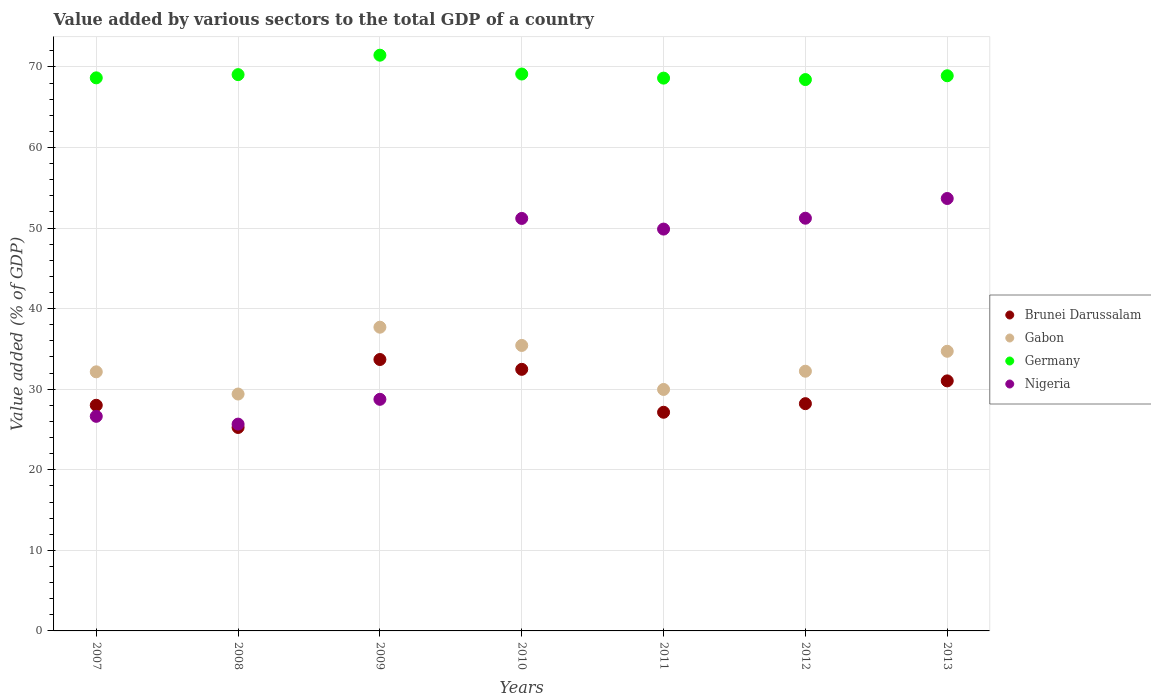Is the number of dotlines equal to the number of legend labels?
Your response must be concise. Yes. What is the value added by various sectors to the total GDP in Gabon in 2007?
Offer a terse response. 32.16. Across all years, what is the maximum value added by various sectors to the total GDP in Germany?
Keep it short and to the point. 71.46. Across all years, what is the minimum value added by various sectors to the total GDP in Germany?
Your response must be concise. 68.43. What is the total value added by various sectors to the total GDP in Germany in the graph?
Your answer should be compact. 484.2. What is the difference between the value added by various sectors to the total GDP in Germany in 2007 and that in 2012?
Provide a succinct answer. 0.21. What is the difference between the value added by various sectors to the total GDP in Gabon in 2011 and the value added by various sectors to the total GDP in Brunei Darussalam in 2012?
Provide a short and direct response. 1.76. What is the average value added by various sectors to the total GDP in Gabon per year?
Ensure brevity in your answer.  33.09. In the year 2007, what is the difference between the value added by various sectors to the total GDP in Gabon and value added by various sectors to the total GDP in Brunei Darussalam?
Your answer should be very brief. 4.15. What is the ratio of the value added by various sectors to the total GDP in Nigeria in 2007 to that in 2009?
Your response must be concise. 0.93. Is the value added by various sectors to the total GDP in Germany in 2010 less than that in 2012?
Provide a short and direct response. No. Is the difference between the value added by various sectors to the total GDP in Gabon in 2012 and 2013 greater than the difference between the value added by various sectors to the total GDP in Brunei Darussalam in 2012 and 2013?
Offer a very short reply. Yes. What is the difference between the highest and the second highest value added by various sectors to the total GDP in Germany?
Provide a succinct answer. 2.34. What is the difference between the highest and the lowest value added by various sectors to the total GDP in Nigeria?
Your answer should be compact. 28. In how many years, is the value added by various sectors to the total GDP in Gabon greater than the average value added by various sectors to the total GDP in Gabon taken over all years?
Your answer should be compact. 3. What is the difference between two consecutive major ticks on the Y-axis?
Your answer should be compact. 10. Where does the legend appear in the graph?
Give a very brief answer. Center right. How many legend labels are there?
Your response must be concise. 4. How are the legend labels stacked?
Offer a terse response. Vertical. What is the title of the graph?
Give a very brief answer. Value added by various sectors to the total GDP of a country. Does "Libya" appear as one of the legend labels in the graph?
Provide a short and direct response. No. What is the label or title of the X-axis?
Your response must be concise. Years. What is the label or title of the Y-axis?
Your response must be concise. Value added (% of GDP). What is the Value added (% of GDP) of Brunei Darussalam in 2007?
Give a very brief answer. 28.01. What is the Value added (% of GDP) in Gabon in 2007?
Give a very brief answer. 32.16. What is the Value added (% of GDP) in Germany in 2007?
Provide a succinct answer. 68.64. What is the Value added (% of GDP) in Nigeria in 2007?
Offer a very short reply. 26.63. What is the Value added (% of GDP) of Brunei Darussalam in 2008?
Ensure brevity in your answer.  25.25. What is the Value added (% of GDP) of Gabon in 2008?
Keep it short and to the point. 29.4. What is the Value added (% of GDP) of Germany in 2008?
Your answer should be very brief. 69.04. What is the Value added (% of GDP) in Nigeria in 2008?
Give a very brief answer. 25.67. What is the Value added (% of GDP) in Brunei Darussalam in 2009?
Keep it short and to the point. 33.69. What is the Value added (% of GDP) in Gabon in 2009?
Your response must be concise. 37.7. What is the Value added (% of GDP) in Germany in 2009?
Your response must be concise. 71.46. What is the Value added (% of GDP) of Nigeria in 2009?
Your answer should be compact. 28.74. What is the Value added (% of GDP) of Brunei Darussalam in 2010?
Provide a short and direct response. 32.47. What is the Value added (% of GDP) in Gabon in 2010?
Make the answer very short. 35.43. What is the Value added (% of GDP) in Germany in 2010?
Offer a very short reply. 69.12. What is the Value added (% of GDP) in Nigeria in 2010?
Make the answer very short. 51.2. What is the Value added (% of GDP) of Brunei Darussalam in 2011?
Give a very brief answer. 27.14. What is the Value added (% of GDP) of Gabon in 2011?
Offer a very short reply. 29.97. What is the Value added (% of GDP) in Germany in 2011?
Ensure brevity in your answer.  68.61. What is the Value added (% of GDP) of Nigeria in 2011?
Give a very brief answer. 49.87. What is the Value added (% of GDP) of Brunei Darussalam in 2012?
Offer a terse response. 28.21. What is the Value added (% of GDP) of Gabon in 2012?
Your response must be concise. 32.23. What is the Value added (% of GDP) of Germany in 2012?
Offer a very short reply. 68.43. What is the Value added (% of GDP) in Nigeria in 2012?
Ensure brevity in your answer.  51.22. What is the Value added (% of GDP) of Brunei Darussalam in 2013?
Your answer should be compact. 31.03. What is the Value added (% of GDP) in Gabon in 2013?
Ensure brevity in your answer.  34.71. What is the Value added (% of GDP) in Germany in 2013?
Keep it short and to the point. 68.9. What is the Value added (% of GDP) in Nigeria in 2013?
Make the answer very short. 53.67. Across all years, what is the maximum Value added (% of GDP) of Brunei Darussalam?
Your answer should be very brief. 33.69. Across all years, what is the maximum Value added (% of GDP) in Gabon?
Your answer should be compact. 37.7. Across all years, what is the maximum Value added (% of GDP) in Germany?
Provide a succinct answer. 71.46. Across all years, what is the maximum Value added (% of GDP) of Nigeria?
Your response must be concise. 53.67. Across all years, what is the minimum Value added (% of GDP) in Brunei Darussalam?
Provide a succinct answer. 25.25. Across all years, what is the minimum Value added (% of GDP) of Gabon?
Ensure brevity in your answer.  29.4. Across all years, what is the minimum Value added (% of GDP) in Germany?
Offer a very short reply. 68.43. Across all years, what is the minimum Value added (% of GDP) in Nigeria?
Ensure brevity in your answer.  25.67. What is the total Value added (% of GDP) in Brunei Darussalam in the graph?
Ensure brevity in your answer.  205.79. What is the total Value added (% of GDP) of Gabon in the graph?
Make the answer very short. 231.6. What is the total Value added (% of GDP) in Germany in the graph?
Your answer should be very brief. 484.2. What is the total Value added (% of GDP) of Nigeria in the graph?
Your response must be concise. 287.01. What is the difference between the Value added (% of GDP) of Brunei Darussalam in 2007 and that in 2008?
Give a very brief answer. 2.75. What is the difference between the Value added (% of GDP) in Gabon in 2007 and that in 2008?
Offer a terse response. 2.76. What is the difference between the Value added (% of GDP) in Germany in 2007 and that in 2008?
Give a very brief answer. -0.4. What is the difference between the Value added (% of GDP) of Nigeria in 2007 and that in 2008?
Offer a very short reply. 0.97. What is the difference between the Value added (% of GDP) of Brunei Darussalam in 2007 and that in 2009?
Offer a terse response. -5.68. What is the difference between the Value added (% of GDP) in Gabon in 2007 and that in 2009?
Your response must be concise. -5.54. What is the difference between the Value added (% of GDP) of Germany in 2007 and that in 2009?
Give a very brief answer. -2.81. What is the difference between the Value added (% of GDP) in Nigeria in 2007 and that in 2009?
Provide a succinct answer. -2.11. What is the difference between the Value added (% of GDP) of Brunei Darussalam in 2007 and that in 2010?
Offer a terse response. -4.46. What is the difference between the Value added (% of GDP) of Gabon in 2007 and that in 2010?
Offer a very short reply. -3.27. What is the difference between the Value added (% of GDP) in Germany in 2007 and that in 2010?
Keep it short and to the point. -0.48. What is the difference between the Value added (% of GDP) of Nigeria in 2007 and that in 2010?
Your answer should be compact. -24.56. What is the difference between the Value added (% of GDP) of Brunei Darussalam in 2007 and that in 2011?
Offer a very short reply. 0.87. What is the difference between the Value added (% of GDP) in Gabon in 2007 and that in 2011?
Your response must be concise. 2.19. What is the difference between the Value added (% of GDP) in Germany in 2007 and that in 2011?
Offer a terse response. 0.03. What is the difference between the Value added (% of GDP) of Nigeria in 2007 and that in 2011?
Give a very brief answer. -23.24. What is the difference between the Value added (% of GDP) in Brunei Darussalam in 2007 and that in 2012?
Ensure brevity in your answer.  -0.2. What is the difference between the Value added (% of GDP) in Gabon in 2007 and that in 2012?
Make the answer very short. -0.08. What is the difference between the Value added (% of GDP) of Germany in 2007 and that in 2012?
Ensure brevity in your answer.  0.21. What is the difference between the Value added (% of GDP) of Nigeria in 2007 and that in 2012?
Your response must be concise. -24.59. What is the difference between the Value added (% of GDP) in Brunei Darussalam in 2007 and that in 2013?
Offer a very short reply. -3.03. What is the difference between the Value added (% of GDP) in Gabon in 2007 and that in 2013?
Make the answer very short. -2.55. What is the difference between the Value added (% of GDP) in Germany in 2007 and that in 2013?
Your response must be concise. -0.26. What is the difference between the Value added (% of GDP) in Nigeria in 2007 and that in 2013?
Offer a terse response. -27.04. What is the difference between the Value added (% of GDP) of Brunei Darussalam in 2008 and that in 2009?
Give a very brief answer. -8.43. What is the difference between the Value added (% of GDP) in Gabon in 2008 and that in 2009?
Offer a very short reply. -8.29. What is the difference between the Value added (% of GDP) of Germany in 2008 and that in 2009?
Give a very brief answer. -2.41. What is the difference between the Value added (% of GDP) of Nigeria in 2008 and that in 2009?
Offer a terse response. -3.08. What is the difference between the Value added (% of GDP) in Brunei Darussalam in 2008 and that in 2010?
Give a very brief answer. -7.22. What is the difference between the Value added (% of GDP) in Gabon in 2008 and that in 2010?
Keep it short and to the point. -6.03. What is the difference between the Value added (% of GDP) in Germany in 2008 and that in 2010?
Offer a terse response. -0.08. What is the difference between the Value added (% of GDP) in Nigeria in 2008 and that in 2010?
Provide a short and direct response. -25.53. What is the difference between the Value added (% of GDP) of Brunei Darussalam in 2008 and that in 2011?
Offer a very short reply. -1.89. What is the difference between the Value added (% of GDP) in Gabon in 2008 and that in 2011?
Provide a short and direct response. -0.57. What is the difference between the Value added (% of GDP) in Germany in 2008 and that in 2011?
Your response must be concise. 0.43. What is the difference between the Value added (% of GDP) in Nigeria in 2008 and that in 2011?
Your answer should be very brief. -24.21. What is the difference between the Value added (% of GDP) of Brunei Darussalam in 2008 and that in 2012?
Offer a very short reply. -2.95. What is the difference between the Value added (% of GDP) in Gabon in 2008 and that in 2012?
Offer a very short reply. -2.83. What is the difference between the Value added (% of GDP) of Germany in 2008 and that in 2012?
Make the answer very short. 0.61. What is the difference between the Value added (% of GDP) of Nigeria in 2008 and that in 2012?
Your answer should be very brief. -25.56. What is the difference between the Value added (% of GDP) of Brunei Darussalam in 2008 and that in 2013?
Your response must be concise. -5.78. What is the difference between the Value added (% of GDP) of Gabon in 2008 and that in 2013?
Offer a terse response. -5.31. What is the difference between the Value added (% of GDP) of Germany in 2008 and that in 2013?
Offer a very short reply. 0.14. What is the difference between the Value added (% of GDP) in Nigeria in 2008 and that in 2013?
Offer a terse response. -28. What is the difference between the Value added (% of GDP) in Brunei Darussalam in 2009 and that in 2010?
Your answer should be compact. 1.22. What is the difference between the Value added (% of GDP) in Gabon in 2009 and that in 2010?
Ensure brevity in your answer.  2.27. What is the difference between the Value added (% of GDP) in Germany in 2009 and that in 2010?
Provide a short and direct response. 2.34. What is the difference between the Value added (% of GDP) in Nigeria in 2009 and that in 2010?
Give a very brief answer. -22.45. What is the difference between the Value added (% of GDP) of Brunei Darussalam in 2009 and that in 2011?
Make the answer very short. 6.55. What is the difference between the Value added (% of GDP) in Gabon in 2009 and that in 2011?
Provide a short and direct response. 7.73. What is the difference between the Value added (% of GDP) in Germany in 2009 and that in 2011?
Your answer should be very brief. 2.85. What is the difference between the Value added (% of GDP) in Nigeria in 2009 and that in 2011?
Offer a terse response. -21.13. What is the difference between the Value added (% of GDP) in Brunei Darussalam in 2009 and that in 2012?
Your answer should be very brief. 5.48. What is the difference between the Value added (% of GDP) in Gabon in 2009 and that in 2012?
Keep it short and to the point. 5.46. What is the difference between the Value added (% of GDP) in Germany in 2009 and that in 2012?
Provide a short and direct response. 3.03. What is the difference between the Value added (% of GDP) in Nigeria in 2009 and that in 2012?
Offer a very short reply. -22.48. What is the difference between the Value added (% of GDP) of Brunei Darussalam in 2009 and that in 2013?
Ensure brevity in your answer.  2.65. What is the difference between the Value added (% of GDP) in Gabon in 2009 and that in 2013?
Your answer should be compact. 2.99. What is the difference between the Value added (% of GDP) of Germany in 2009 and that in 2013?
Your answer should be very brief. 2.55. What is the difference between the Value added (% of GDP) of Nigeria in 2009 and that in 2013?
Give a very brief answer. -24.93. What is the difference between the Value added (% of GDP) in Brunei Darussalam in 2010 and that in 2011?
Ensure brevity in your answer.  5.33. What is the difference between the Value added (% of GDP) of Gabon in 2010 and that in 2011?
Offer a terse response. 5.46. What is the difference between the Value added (% of GDP) of Germany in 2010 and that in 2011?
Offer a very short reply. 0.51. What is the difference between the Value added (% of GDP) of Nigeria in 2010 and that in 2011?
Give a very brief answer. 1.32. What is the difference between the Value added (% of GDP) in Brunei Darussalam in 2010 and that in 2012?
Provide a succinct answer. 4.26. What is the difference between the Value added (% of GDP) of Gabon in 2010 and that in 2012?
Provide a succinct answer. 3.2. What is the difference between the Value added (% of GDP) of Germany in 2010 and that in 2012?
Your response must be concise. 0.69. What is the difference between the Value added (% of GDP) in Nigeria in 2010 and that in 2012?
Offer a very short reply. -0.03. What is the difference between the Value added (% of GDP) in Brunei Darussalam in 2010 and that in 2013?
Offer a terse response. 1.43. What is the difference between the Value added (% of GDP) of Gabon in 2010 and that in 2013?
Give a very brief answer. 0.72. What is the difference between the Value added (% of GDP) of Germany in 2010 and that in 2013?
Your response must be concise. 0.22. What is the difference between the Value added (% of GDP) in Nigeria in 2010 and that in 2013?
Give a very brief answer. -2.47. What is the difference between the Value added (% of GDP) of Brunei Darussalam in 2011 and that in 2012?
Offer a very short reply. -1.07. What is the difference between the Value added (% of GDP) of Gabon in 2011 and that in 2012?
Your answer should be very brief. -2.26. What is the difference between the Value added (% of GDP) in Germany in 2011 and that in 2012?
Offer a very short reply. 0.18. What is the difference between the Value added (% of GDP) in Nigeria in 2011 and that in 2012?
Make the answer very short. -1.35. What is the difference between the Value added (% of GDP) of Brunei Darussalam in 2011 and that in 2013?
Keep it short and to the point. -3.9. What is the difference between the Value added (% of GDP) of Gabon in 2011 and that in 2013?
Ensure brevity in your answer.  -4.74. What is the difference between the Value added (% of GDP) in Germany in 2011 and that in 2013?
Keep it short and to the point. -0.29. What is the difference between the Value added (% of GDP) of Nigeria in 2011 and that in 2013?
Your answer should be compact. -3.8. What is the difference between the Value added (% of GDP) of Brunei Darussalam in 2012 and that in 2013?
Keep it short and to the point. -2.83. What is the difference between the Value added (% of GDP) of Gabon in 2012 and that in 2013?
Provide a short and direct response. -2.48. What is the difference between the Value added (% of GDP) of Germany in 2012 and that in 2013?
Keep it short and to the point. -0.47. What is the difference between the Value added (% of GDP) in Nigeria in 2012 and that in 2013?
Offer a very short reply. -2.45. What is the difference between the Value added (% of GDP) in Brunei Darussalam in 2007 and the Value added (% of GDP) in Gabon in 2008?
Ensure brevity in your answer.  -1.4. What is the difference between the Value added (% of GDP) in Brunei Darussalam in 2007 and the Value added (% of GDP) in Germany in 2008?
Give a very brief answer. -41.04. What is the difference between the Value added (% of GDP) of Brunei Darussalam in 2007 and the Value added (% of GDP) of Nigeria in 2008?
Offer a terse response. 2.34. What is the difference between the Value added (% of GDP) of Gabon in 2007 and the Value added (% of GDP) of Germany in 2008?
Your answer should be very brief. -36.89. What is the difference between the Value added (% of GDP) in Gabon in 2007 and the Value added (% of GDP) in Nigeria in 2008?
Provide a short and direct response. 6.49. What is the difference between the Value added (% of GDP) in Germany in 2007 and the Value added (% of GDP) in Nigeria in 2008?
Provide a short and direct response. 42.98. What is the difference between the Value added (% of GDP) of Brunei Darussalam in 2007 and the Value added (% of GDP) of Gabon in 2009?
Offer a very short reply. -9.69. What is the difference between the Value added (% of GDP) of Brunei Darussalam in 2007 and the Value added (% of GDP) of Germany in 2009?
Provide a succinct answer. -43.45. What is the difference between the Value added (% of GDP) in Brunei Darussalam in 2007 and the Value added (% of GDP) in Nigeria in 2009?
Offer a terse response. -0.74. What is the difference between the Value added (% of GDP) of Gabon in 2007 and the Value added (% of GDP) of Germany in 2009?
Make the answer very short. -39.3. What is the difference between the Value added (% of GDP) of Gabon in 2007 and the Value added (% of GDP) of Nigeria in 2009?
Keep it short and to the point. 3.41. What is the difference between the Value added (% of GDP) of Germany in 2007 and the Value added (% of GDP) of Nigeria in 2009?
Ensure brevity in your answer.  39.9. What is the difference between the Value added (% of GDP) in Brunei Darussalam in 2007 and the Value added (% of GDP) in Gabon in 2010?
Provide a short and direct response. -7.43. What is the difference between the Value added (% of GDP) in Brunei Darussalam in 2007 and the Value added (% of GDP) in Germany in 2010?
Your answer should be very brief. -41.11. What is the difference between the Value added (% of GDP) in Brunei Darussalam in 2007 and the Value added (% of GDP) in Nigeria in 2010?
Your answer should be very brief. -23.19. What is the difference between the Value added (% of GDP) of Gabon in 2007 and the Value added (% of GDP) of Germany in 2010?
Your answer should be compact. -36.96. What is the difference between the Value added (% of GDP) in Gabon in 2007 and the Value added (% of GDP) in Nigeria in 2010?
Provide a short and direct response. -19.04. What is the difference between the Value added (% of GDP) in Germany in 2007 and the Value added (% of GDP) in Nigeria in 2010?
Give a very brief answer. 17.45. What is the difference between the Value added (% of GDP) of Brunei Darussalam in 2007 and the Value added (% of GDP) of Gabon in 2011?
Give a very brief answer. -1.96. What is the difference between the Value added (% of GDP) of Brunei Darussalam in 2007 and the Value added (% of GDP) of Germany in 2011?
Your answer should be compact. -40.61. What is the difference between the Value added (% of GDP) of Brunei Darussalam in 2007 and the Value added (% of GDP) of Nigeria in 2011?
Your answer should be compact. -21.87. What is the difference between the Value added (% of GDP) of Gabon in 2007 and the Value added (% of GDP) of Germany in 2011?
Your answer should be compact. -36.45. What is the difference between the Value added (% of GDP) in Gabon in 2007 and the Value added (% of GDP) in Nigeria in 2011?
Give a very brief answer. -17.72. What is the difference between the Value added (% of GDP) in Germany in 2007 and the Value added (% of GDP) in Nigeria in 2011?
Your answer should be very brief. 18.77. What is the difference between the Value added (% of GDP) in Brunei Darussalam in 2007 and the Value added (% of GDP) in Gabon in 2012?
Offer a very short reply. -4.23. What is the difference between the Value added (% of GDP) of Brunei Darussalam in 2007 and the Value added (% of GDP) of Germany in 2012?
Ensure brevity in your answer.  -40.42. What is the difference between the Value added (% of GDP) of Brunei Darussalam in 2007 and the Value added (% of GDP) of Nigeria in 2012?
Keep it short and to the point. -23.22. What is the difference between the Value added (% of GDP) in Gabon in 2007 and the Value added (% of GDP) in Germany in 2012?
Your answer should be very brief. -36.27. What is the difference between the Value added (% of GDP) of Gabon in 2007 and the Value added (% of GDP) of Nigeria in 2012?
Offer a terse response. -19.07. What is the difference between the Value added (% of GDP) of Germany in 2007 and the Value added (% of GDP) of Nigeria in 2012?
Provide a succinct answer. 17.42. What is the difference between the Value added (% of GDP) of Brunei Darussalam in 2007 and the Value added (% of GDP) of Gabon in 2013?
Offer a very short reply. -6.7. What is the difference between the Value added (% of GDP) in Brunei Darussalam in 2007 and the Value added (% of GDP) in Germany in 2013?
Provide a short and direct response. -40.9. What is the difference between the Value added (% of GDP) of Brunei Darussalam in 2007 and the Value added (% of GDP) of Nigeria in 2013?
Offer a very short reply. -25.66. What is the difference between the Value added (% of GDP) in Gabon in 2007 and the Value added (% of GDP) in Germany in 2013?
Offer a very short reply. -36.75. What is the difference between the Value added (% of GDP) in Gabon in 2007 and the Value added (% of GDP) in Nigeria in 2013?
Your answer should be very brief. -21.51. What is the difference between the Value added (% of GDP) of Germany in 2007 and the Value added (% of GDP) of Nigeria in 2013?
Your answer should be very brief. 14.97. What is the difference between the Value added (% of GDP) in Brunei Darussalam in 2008 and the Value added (% of GDP) in Gabon in 2009?
Offer a terse response. -12.45. What is the difference between the Value added (% of GDP) in Brunei Darussalam in 2008 and the Value added (% of GDP) in Germany in 2009?
Your answer should be compact. -46.2. What is the difference between the Value added (% of GDP) of Brunei Darussalam in 2008 and the Value added (% of GDP) of Nigeria in 2009?
Offer a very short reply. -3.49. What is the difference between the Value added (% of GDP) in Gabon in 2008 and the Value added (% of GDP) in Germany in 2009?
Your answer should be compact. -42.05. What is the difference between the Value added (% of GDP) in Gabon in 2008 and the Value added (% of GDP) in Nigeria in 2009?
Offer a very short reply. 0.66. What is the difference between the Value added (% of GDP) of Germany in 2008 and the Value added (% of GDP) of Nigeria in 2009?
Keep it short and to the point. 40.3. What is the difference between the Value added (% of GDP) of Brunei Darussalam in 2008 and the Value added (% of GDP) of Gabon in 2010?
Your response must be concise. -10.18. What is the difference between the Value added (% of GDP) in Brunei Darussalam in 2008 and the Value added (% of GDP) in Germany in 2010?
Provide a succinct answer. -43.87. What is the difference between the Value added (% of GDP) of Brunei Darussalam in 2008 and the Value added (% of GDP) of Nigeria in 2010?
Make the answer very short. -25.94. What is the difference between the Value added (% of GDP) in Gabon in 2008 and the Value added (% of GDP) in Germany in 2010?
Your answer should be very brief. -39.72. What is the difference between the Value added (% of GDP) in Gabon in 2008 and the Value added (% of GDP) in Nigeria in 2010?
Offer a terse response. -21.79. What is the difference between the Value added (% of GDP) of Germany in 2008 and the Value added (% of GDP) of Nigeria in 2010?
Offer a terse response. 17.85. What is the difference between the Value added (% of GDP) of Brunei Darussalam in 2008 and the Value added (% of GDP) of Gabon in 2011?
Ensure brevity in your answer.  -4.72. What is the difference between the Value added (% of GDP) in Brunei Darussalam in 2008 and the Value added (% of GDP) in Germany in 2011?
Ensure brevity in your answer.  -43.36. What is the difference between the Value added (% of GDP) of Brunei Darussalam in 2008 and the Value added (% of GDP) of Nigeria in 2011?
Offer a very short reply. -24.62. What is the difference between the Value added (% of GDP) of Gabon in 2008 and the Value added (% of GDP) of Germany in 2011?
Give a very brief answer. -39.21. What is the difference between the Value added (% of GDP) in Gabon in 2008 and the Value added (% of GDP) in Nigeria in 2011?
Offer a terse response. -20.47. What is the difference between the Value added (% of GDP) in Germany in 2008 and the Value added (% of GDP) in Nigeria in 2011?
Keep it short and to the point. 19.17. What is the difference between the Value added (% of GDP) of Brunei Darussalam in 2008 and the Value added (% of GDP) of Gabon in 2012?
Ensure brevity in your answer.  -6.98. What is the difference between the Value added (% of GDP) of Brunei Darussalam in 2008 and the Value added (% of GDP) of Germany in 2012?
Ensure brevity in your answer.  -43.18. What is the difference between the Value added (% of GDP) of Brunei Darussalam in 2008 and the Value added (% of GDP) of Nigeria in 2012?
Give a very brief answer. -25.97. What is the difference between the Value added (% of GDP) in Gabon in 2008 and the Value added (% of GDP) in Germany in 2012?
Ensure brevity in your answer.  -39.03. What is the difference between the Value added (% of GDP) of Gabon in 2008 and the Value added (% of GDP) of Nigeria in 2012?
Provide a succinct answer. -21.82. What is the difference between the Value added (% of GDP) of Germany in 2008 and the Value added (% of GDP) of Nigeria in 2012?
Ensure brevity in your answer.  17.82. What is the difference between the Value added (% of GDP) in Brunei Darussalam in 2008 and the Value added (% of GDP) in Gabon in 2013?
Provide a succinct answer. -9.46. What is the difference between the Value added (% of GDP) of Brunei Darussalam in 2008 and the Value added (% of GDP) of Germany in 2013?
Your answer should be compact. -43.65. What is the difference between the Value added (% of GDP) of Brunei Darussalam in 2008 and the Value added (% of GDP) of Nigeria in 2013?
Your answer should be very brief. -28.42. What is the difference between the Value added (% of GDP) of Gabon in 2008 and the Value added (% of GDP) of Germany in 2013?
Offer a terse response. -39.5. What is the difference between the Value added (% of GDP) of Gabon in 2008 and the Value added (% of GDP) of Nigeria in 2013?
Ensure brevity in your answer.  -24.27. What is the difference between the Value added (% of GDP) of Germany in 2008 and the Value added (% of GDP) of Nigeria in 2013?
Provide a short and direct response. 15.37. What is the difference between the Value added (% of GDP) in Brunei Darussalam in 2009 and the Value added (% of GDP) in Gabon in 2010?
Make the answer very short. -1.75. What is the difference between the Value added (% of GDP) of Brunei Darussalam in 2009 and the Value added (% of GDP) of Germany in 2010?
Provide a short and direct response. -35.43. What is the difference between the Value added (% of GDP) of Brunei Darussalam in 2009 and the Value added (% of GDP) of Nigeria in 2010?
Your answer should be compact. -17.51. What is the difference between the Value added (% of GDP) in Gabon in 2009 and the Value added (% of GDP) in Germany in 2010?
Your answer should be very brief. -31.42. What is the difference between the Value added (% of GDP) of Gabon in 2009 and the Value added (% of GDP) of Nigeria in 2010?
Your answer should be very brief. -13.5. What is the difference between the Value added (% of GDP) in Germany in 2009 and the Value added (% of GDP) in Nigeria in 2010?
Make the answer very short. 20.26. What is the difference between the Value added (% of GDP) of Brunei Darussalam in 2009 and the Value added (% of GDP) of Gabon in 2011?
Make the answer very short. 3.72. What is the difference between the Value added (% of GDP) in Brunei Darussalam in 2009 and the Value added (% of GDP) in Germany in 2011?
Ensure brevity in your answer.  -34.92. What is the difference between the Value added (% of GDP) of Brunei Darussalam in 2009 and the Value added (% of GDP) of Nigeria in 2011?
Your answer should be very brief. -16.19. What is the difference between the Value added (% of GDP) in Gabon in 2009 and the Value added (% of GDP) in Germany in 2011?
Ensure brevity in your answer.  -30.91. What is the difference between the Value added (% of GDP) of Gabon in 2009 and the Value added (% of GDP) of Nigeria in 2011?
Your answer should be compact. -12.18. What is the difference between the Value added (% of GDP) of Germany in 2009 and the Value added (% of GDP) of Nigeria in 2011?
Your answer should be very brief. 21.58. What is the difference between the Value added (% of GDP) in Brunei Darussalam in 2009 and the Value added (% of GDP) in Gabon in 2012?
Provide a succinct answer. 1.45. What is the difference between the Value added (% of GDP) of Brunei Darussalam in 2009 and the Value added (% of GDP) of Germany in 2012?
Your answer should be compact. -34.74. What is the difference between the Value added (% of GDP) of Brunei Darussalam in 2009 and the Value added (% of GDP) of Nigeria in 2012?
Your answer should be very brief. -17.54. What is the difference between the Value added (% of GDP) of Gabon in 2009 and the Value added (% of GDP) of Germany in 2012?
Your response must be concise. -30.73. What is the difference between the Value added (% of GDP) in Gabon in 2009 and the Value added (% of GDP) in Nigeria in 2012?
Your answer should be compact. -13.53. What is the difference between the Value added (% of GDP) in Germany in 2009 and the Value added (% of GDP) in Nigeria in 2012?
Offer a very short reply. 20.23. What is the difference between the Value added (% of GDP) of Brunei Darussalam in 2009 and the Value added (% of GDP) of Gabon in 2013?
Ensure brevity in your answer.  -1.02. What is the difference between the Value added (% of GDP) of Brunei Darussalam in 2009 and the Value added (% of GDP) of Germany in 2013?
Provide a succinct answer. -35.22. What is the difference between the Value added (% of GDP) of Brunei Darussalam in 2009 and the Value added (% of GDP) of Nigeria in 2013?
Offer a terse response. -19.98. What is the difference between the Value added (% of GDP) in Gabon in 2009 and the Value added (% of GDP) in Germany in 2013?
Provide a short and direct response. -31.21. What is the difference between the Value added (% of GDP) in Gabon in 2009 and the Value added (% of GDP) in Nigeria in 2013?
Your response must be concise. -15.97. What is the difference between the Value added (% of GDP) of Germany in 2009 and the Value added (% of GDP) of Nigeria in 2013?
Provide a succinct answer. 17.79. What is the difference between the Value added (% of GDP) of Brunei Darussalam in 2010 and the Value added (% of GDP) of Gabon in 2011?
Offer a very short reply. 2.5. What is the difference between the Value added (% of GDP) of Brunei Darussalam in 2010 and the Value added (% of GDP) of Germany in 2011?
Ensure brevity in your answer.  -36.14. What is the difference between the Value added (% of GDP) in Brunei Darussalam in 2010 and the Value added (% of GDP) in Nigeria in 2011?
Offer a terse response. -17.41. What is the difference between the Value added (% of GDP) in Gabon in 2010 and the Value added (% of GDP) in Germany in 2011?
Offer a terse response. -33.18. What is the difference between the Value added (% of GDP) in Gabon in 2010 and the Value added (% of GDP) in Nigeria in 2011?
Make the answer very short. -14.44. What is the difference between the Value added (% of GDP) in Germany in 2010 and the Value added (% of GDP) in Nigeria in 2011?
Offer a very short reply. 19.24. What is the difference between the Value added (% of GDP) of Brunei Darussalam in 2010 and the Value added (% of GDP) of Gabon in 2012?
Ensure brevity in your answer.  0.23. What is the difference between the Value added (% of GDP) in Brunei Darussalam in 2010 and the Value added (% of GDP) in Germany in 2012?
Your response must be concise. -35.96. What is the difference between the Value added (% of GDP) of Brunei Darussalam in 2010 and the Value added (% of GDP) of Nigeria in 2012?
Ensure brevity in your answer.  -18.76. What is the difference between the Value added (% of GDP) in Gabon in 2010 and the Value added (% of GDP) in Germany in 2012?
Make the answer very short. -33. What is the difference between the Value added (% of GDP) of Gabon in 2010 and the Value added (% of GDP) of Nigeria in 2012?
Provide a succinct answer. -15.79. What is the difference between the Value added (% of GDP) in Germany in 2010 and the Value added (% of GDP) in Nigeria in 2012?
Your answer should be compact. 17.9. What is the difference between the Value added (% of GDP) in Brunei Darussalam in 2010 and the Value added (% of GDP) in Gabon in 2013?
Offer a very short reply. -2.24. What is the difference between the Value added (% of GDP) in Brunei Darussalam in 2010 and the Value added (% of GDP) in Germany in 2013?
Offer a terse response. -36.44. What is the difference between the Value added (% of GDP) in Brunei Darussalam in 2010 and the Value added (% of GDP) in Nigeria in 2013?
Give a very brief answer. -21.2. What is the difference between the Value added (% of GDP) in Gabon in 2010 and the Value added (% of GDP) in Germany in 2013?
Provide a succinct answer. -33.47. What is the difference between the Value added (% of GDP) in Gabon in 2010 and the Value added (% of GDP) in Nigeria in 2013?
Offer a very short reply. -18.24. What is the difference between the Value added (% of GDP) in Germany in 2010 and the Value added (% of GDP) in Nigeria in 2013?
Your answer should be very brief. 15.45. What is the difference between the Value added (% of GDP) in Brunei Darussalam in 2011 and the Value added (% of GDP) in Gabon in 2012?
Give a very brief answer. -5.09. What is the difference between the Value added (% of GDP) of Brunei Darussalam in 2011 and the Value added (% of GDP) of Germany in 2012?
Offer a very short reply. -41.29. What is the difference between the Value added (% of GDP) of Brunei Darussalam in 2011 and the Value added (% of GDP) of Nigeria in 2012?
Your answer should be compact. -24.08. What is the difference between the Value added (% of GDP) of Gabon in 2011 and the Value added (% of GDP) of Germany in 2012?
Your answer should be compact. -38.46. What is the difference between the Value added (% of GDP) in Gabon in 2011 and the Value added (% of GDP) in Nigeria in 2012?
Offer a very short reply. -21.25. What is the difference between the Value added (% of GDP) of Germany in 2011 and the Value added (% of GDP) of Nigeria in 2012?
Offer a terse response. 17.39. What is the difference between the Value added (% of GDP) of Brunei Darussalam in 2011 and the Value added (% of GDP) of Gabon in 2013?
Provide a short and direct response. -7.57. What is the difference between the Value added (% of GDP) of Brunei Darussalam in 2011 and the Value added (% of GDP) of Germany in 2013?
Keep it short and to the point. -41.76. What is the difference between the Value added (% of GDP) in Brunei Darussalam in 2011 and the Value added (% of GDP) in Nigeria in 2013?
Make the answer very short. -26.53. What is the difference between the Value added (% of GDP) in Gabon in 2011 and the Value added (% of GDP) in Germany in 2013?
Your answer should be compact. -38.93. What is the difference between the Value added (% of GDP) of Gabon in 2011 and the Value added (% of GDP) of Nigeria in 2013?
Your answer should be compact. -23.7. What is the difference between the Value added (% of GDP) of Germany in 2011 and the Value added (% of GDP) of Nigeria in 2013?
Ensure brevity in your answer.  14.94. What is the difference between the Value added (% of GDP) in Brunei Darussalam in 2012 and the Value added (% of GDP) in Gabon in 2013?
Give a very brief answer. -6.5. What is the difference between the Value added (% of GDP) of Brunei Darussalam in 2012 and the Value added (% of GDP) of Germany in 2013?
Your answer should be compact. -40.7. What is the difference between the Value added (% of GDP) of Brunei Darussalam in 2012 and the Value added (% of GDP) of Nigeria in 2013?
Offer a terse response. -25.46. What is the difference between the Value added (% of GDP) of Gabon in 2012 and the Value added (% of GDP) of Germany in 2013?
Offer a terse response. -36.67. What is the difference between the Value added (% of GDP) of Gabon in 2012 and the Value added (% of GDP) of Nigeria in 2013?
Your answer should be compact. -21.44. What is the difference between the Value added (% of GDP) of Germany in 2012 and the Value added (% of GDP) of Nigeria in 2013?
Your response must be concise. 14.76. What is the average Value added (% of GDP) of Brunei Darussalam per year?
Make the answer very short. 29.4. What is the average Value added (% of GDP) of Gabon per year?
Your answer should be very brief. 33.09. What is the average Value added (% of GDP) of Germany per year?
Keep it short and to the point. 69.17. What is the average Value added (% of GDP) of Nigeria per year?
Your response must be concise. 41. In the year 2007, what is the difference between the Value added (% of GDP) of Brunei Darussalam and Value added (% of GDP) of Gabon?
Keep it short and to the point. -4.15. In the year 2007, what is the difference between the Value added (% of GDP) of Brunei Darussalam and Value added (% of GDP) of Germany?
Provide a succinct answer. -40.64. In the year 2007, what is the difference between the Value added (% of GDP) in Brunei Darussalam and Value added (% of GDP) in Nigeria?
Offer a very short reply. 1.37. In the year 2007, what is the difference between the Value added (% of GDP) of Gabon and Value added (% of GDP) of Germany?
Ensure brevity in your answer.  -36.49. In the year 2007, what is the difference between the Value added (% of GDP) in Gabon and Value added (% of GDP) in Nigeria?
Your answer should be compact. 5.52. In the year 2007, what is the difference between the Value added (% of GDP) in Germany and Value added (% of GDP) in Nigeria?
Keep it short and to the point. 42.01. In the year 2008, what is the difference between the Value added (% of GDP) of Brunei Darussalam and Value added (% of GDP) of Gabon?
Offer a terse response. -4.15. In the year 2008, what is the difference between the Value added (% of GDP) of Brunei Darussalam and Value added (% of GDP) of Germany?
Offer a very short reply. -43.79. In the year 2008, what is the difference between the Value added (% of GDP) in Brunei Darussalam and Value added (% of GDP) in Nigeria?
Make the answer very short. -0.42. In the year 2008, what is the difference between the Value added (% of GDP) of Gabon and Value added (% of GDP) of Germany?
Your response must be concise. -39.64. In the year 2008, what is the difference between the Value added (% of GDP) of Gabon and Value added (% of GDP) of Nigeria?
Make the answer very short. 3.73. In the year 2008, what is the difference between the Value added (% of GDP) of Germany and Value added (% of GDP) of Nigeria?
Provide a succinct answer. 43.38. In the year 2009, what is the difference between the Value added (% of GDP) in Brunei Darussalam and Value added (% of GDP) in Gabon?
Offer a very short reply. -4.01. In the year 2009, what is the difference between the Value added (% of GDP) of Brunei Darussalam and Value added (% of GDP) of Germany?
Keep it short and to the point. -37.77. In the year 2009, what is the difference between the Value added (% of GDP) of Brunei Darussalam and Value added (% of GDP) of Nigeria?
Offer a very short reply. 4.94. In the year 2009, what is the difference between the Value added (% of GDP) of Gabon and Value added (% of GDP) of Germany?
Ensure brevity in your answer.  -33.76. In the year 2009, what is the difference between the Value added (% of GDP) of Gabon and Value added (% of GDP) of Nigeria?
Your answer should be very brief. 8.95. In the year 2009, what is the difference between the Value added (% of GDP) in Germany and Value added (% of GDP) in Nigeria?
Offer a terse response. 42.71. In the year 2010, what is the difference between the Value added (% of GDP) of Brunei Darussalam and Value added (% of GDP) of Gabon?
Your answer should be compact. -2.96. In the year 2010, what is the difference between the Value added (% of GDP) of Brunei Darussalam and Value added (% of GDP) of Germany?
Provide a succinct answer. -36.65. In the year 2010, what is the difference between the Value added (% of GDP) in Brunei Darussalam and Value added (% of GDP) in Nigeria?
Keep it short and to the point. -18.73. In the year 2010, what is the difference between the Value added (% of GDP) in Gabon and Value added (% of GDP) in Germany?
Keep it short and to the point. -33.69. In the year 2010, what is the difference between the Value added (% of GDP) in Gabon and Value added (% of GDP) in Nigeria?
Offer a very short reply. -15.76. In the year 2010, what is the difference between the Value added (% of GDP) in Germany and Value added (% of GDP) in Nigeria?
Provide a short and direct response. 17.92. In the year 2011, what is the difference between the Value added (% of GDP) of Brunei Darussalam and Value added (% of GDP) of Gabon?
Ensure brevity in your answer.  -2.83. In the year 2011, what is the difference between the Value added (% of GDP) in Brunei Darussalam and Value added (% of GDP) in Germany?
Give a very brief answer. -41.47. In the year 2011, what is the difference between the Value added (% of GDP) in Brunei Darussalam and Value added (% of GDP) in Nigeria?
Provide a succinct answer. -22.73. In the year 2011, what is the difference between the Value added (% of GDP) of Gabon and Value added (% of GDP) of Germany?
Give a very brief answer. -38.64. In the year 2011, what is the difference between the Value added (% of GDP) of Gabon and Value added (% of GDP) of Nigeria?
Keep it short and to the point. -19.9. In the year 2011, what is the difference between the Value added (% of GDP) of Germany and Value added (% of GDP) of Nigeria?
Your response must be concise. 18.74. In the year 2012, what is the difference between the Value added (% of GDP) in Brunei Darussalam and Value added (% of GDP) in Gabon?
Provide a succinct answer. -4.03. In the year 2012, what is the difference between the Value added (% of GDP) of Brunei Darussalam and Value added (% of GDP) of Germany?
Provide a short and direct response. -40.22. In the year 2012, what is the difference between the Value added (% of GDP) of Brunei Darussalam and Value added (% of GDP) of Nigeria?
Keep it short and to the point. -23.02. In the year 2012, what is the difference between the Value added (% of GDP) in Gabon and Value added (% of GDP) in Germany?
Offer a very short reply. -36.2. In the year 2012, what is the difference between the Value added (% of GDP) of Gabon and Value added (% of GDP) of Nigeria?
Keep it short and to the point. -18.99. In the year 2012, what is the difference between the Value added (% of GDP) of Germany and Value added (% of GDP) of Nigeria?
Offer a very short reply. 17.21. In the year 2013, what is the difference between the Value added (% of GDP) in Brunei Darussalam and Value added (% of GDP) in Gabon?
Provide a short and direct response. -3.67. In the year 2013, what is the difference between the Value added (% of GDP) of Brunei Darussalam and Value added (% of GDP) of Germany?
Make the answer very short. -37.87. In the year 2013, what is the difference between the Value added (% of GDP) in Brunei Darussalam and Value added (% of GDP) in Nigeria?
Your answer should be very brief. -22.64. In the year 2013, what is the difference between the Value added (% of GDP) in Gabon and Value added (% of GDP) in Germany?
Keep it short and to the point. -34.19. In the year 2013, what is the difference between the Value added (% of GDP) in Gabon and Value added (% of GDP) in Nigeria?
Give a very brief answer. -18.96. In the year 2013, what is the difference between the Value added (% of GDP) of Germany and Value added (% of GDP) of Nigeria?
Keep it short and to the point. 15.23. What is the ratio of the Value added (% of GDP) of Brunei Darussalam in 2007 to that in 2008?
Make the answer very short. 1.11. What is the ratio of the Value added (% of GDP) in Gabon in 2007 to that in 2008?
Your answer should be very brief. 1.09. What is the ratio of the Value added (% of GDP) of Nigeria in 2007 to that in 2008?
Ensure brevity in your answer.  1.04. What is the ratio of the Value added (% of GDP) in Brunei Darussalam in 2007 to that in 2009?
Your answer should be compact. 0.83. What is the ratio of the Value added (% of GDP) of Gabon in 2007 to that in 2009?
Keep it short and to the point. 0.85. What is the ratio of the Value added (% of GDP) in Germany in 2007 to that in 2009?
Ensure brevity in your answer.  0.96. What is the ratio of the Value added (% of GDP) of Nigeria in 2007 to that in 2009?
Provide a succinct answer. 0.93. What is the ratio of the Value added (% of GDP) in Brunei Darussalam in 2007 to that in 2010?
Your answer should be compact. 0.86. What is the ratio of the Value added (% of GDP) of Gabon in 2007 to that in 2010?
Make the answer very short. 0.91. What is the ratio of the Value added (% of GDP) of Nigeria in 2007 to that in 2010?
Your answer should be very brief. 0.52. What is the ratio of the Value added (% of GDP) of Brunei Darussalam in 2007 to that in 2011?
Make the answer very short. 1.03. What is the ratio of the Value added (% of GDP) of Gabon in 2007 to that in 2011?
Your answer should be very brief. 1.07. What is the ratio of the Value added (% of GDP) of Nigeria in 2007 to that in 2011?
Provide a short and direct response. 0.53. What is the ratio of the Value added (% of GDP) in Gabon in 2007 to that in 2012?
Offer a terse response. 1. What is the ratio of the Value added (% of GDP) of Nigeria in 2007 to that in 2012?
Offer a very short reply. 0.52. What is the ratio of the Value added (% of GDP) of Brunei Darussalam in 2007 to that in 2013?
Your answer should be very brief. 0.9. What is the ratio of the Value added (% of GDP) of Gabon in 2007 to that in 2013?
Offer a terse response. 0.93. What is the ratio of the Value added (% of GDP) in Nigeria in 2007 to that in 2013?
Make the answer very short. 0.5. What is the ratio of the Value added (% of GDP) of Brunei Darussalam in 2008 to that in 2009?
Offer a terse response. 0.75. What is the ratio of the Value added (% of GDP) of Gabon in 2008 to that in 2009?
Provide a short and direct response. 0.78. What is the ratio of the Value added (% of GDP) in Germany in 2008 to that in 2009?
Ensure brevity in your answer.  0.97. What is the ratio of the Value added (% of GDP) in Nigeria in 2008 to that in 2009?
Provide a succinct answer. 0.89. What is the ratio of the Value added (% of GDP) of Brunei Darussalam in 2008 to that in 2010?
Offer a terse response. 0.78. What is the ratio of the Value added (% of GDP) in Gabon in 2008 to that in 2010?
Make the answer very short. 0.83. What is the ratio of the Value added (% of GDP) of Germany in 2008 to that in 2010?
Provide a succinct answer. 1. What is the ratio of the Value added (% of GDP) of Nigeria in 2008 to that in 2010?
Keep it short and to the point. 0.5. What is the ratio of the Value added (% of GDP) in Brunei Darussalam in 2008 to that in 2011?
Provide a succinct answer. 0.93. What is the ratio of the Value added (% of GDP) of Gabon in 2008 to that in 2011?
Your answer should be compact. 0.98. What is the ratio of the Value added (% of GDP) of Nigeria in 2008 to that in 2011?
Provide a succinct answer. 0.51. What is the ratio of the Value added (% of GDP) of Brunei Darussalam in 2008 to that in 2012?
Ensure brevity in your answer.  0.9. What is the ratio of the Value added (% of GDP) of Gabon in 2008 to that in 2012?
Offer a terse response. 0.91. What is the ratio of the Value added (% of GDP) in Germany in 2008 to that in 2012?
Give a very brief answer. 1.01. What is the ratio of the Value added (% of GDP) of Nigeria in 2008 to that in 2012?
Your response must be concise. 0.5. What is the ratio of the Value added (% of GDP) in Brunei Darussalam in 2008 to that in 2013?
Offer a terse response. 0.81. What is the ratio of the Value added (% of GDP) of Gabon in 2008 to that in 2013?
Offer a terse response. 0.85. What is the ratio of the Value added (% of GDP) of Germany in 2008 to that in 2013?
Make the answer very short. 1. What is the ratio of the Value added (% of GDP) of Nigeria in 2008 to that in 2013?
Provide a succinct answer. 0.48. What is the ratio of the Value added (% of GDP) of Brunei Darussalam in 2009 to that in 2010?
Ensure brevity in your answer.  1.04. What is the ratio of the Value added (% of GDP) in Gabon in 2009 to that in 2010?
Keep it short and to the point. 1.06. What is the ratio of the Value added (% of GDP) of Germany in 2009 to that in 2010?
Provide a short and direct response. 1.03. What is the ratio of the Value added (% of GDP) in Nigeria in 2009 to that in 2010?
Offer a very short reply. 0.56. What is the ratio of the Value added (% of GDP) in Brunei Darussalam in 2009 to that in 2011?
Your response must be concise. 1.24. What is the ratio of the Value added (% of GDP) of Gabon in 2009 to that in 2011?
Provide a short and direct response. 1.26. What is the ratio of the Value added (% of GDP) of Germany in 2009 to that in 2011?
Offer a very short reply. 1.04. What is the ratio of the Value added (% of GDP) of Nigeria in 2009 to that in 2011?
Your answer should be compact. 0.58. What is the ratio of the Value added (% of GDP) in Brunei Darussalam in 2009 to that in 2012?
Your answer should be compact. 1.19. What is the ratio of the Value added (% of GDP) in Gabon in 2009 to that in 2012?
Provide a succinct answer. 1.17. What is the ratio of the Value added (% of GDP) in Germany in 2009 to that in 2012?
Provide a succinct answer. 1.04. What is the ratio of the Value added (% of GDP) in Nigeria in 2009 to that in 2012?
Provide a succinct answer. 0.56. What is the ratio of the Value added (% of GDP) in Brunei Darussalam in 2009 to that in 2013?
Your answer should be very brief. 1.09. What is the ratio of the Value added (% of GDP) in Gabon in 2009 to that in 2013?
Ensure brevity in your answer.  1.09. What is the ratio of the Value added (% of GDP) in Germany in 2009 to that in 2013?
Your response must be concise. 1.04. What is the ratio of the Value added (% of GDP) of Nigeria in 2009 to that in 2013?
Provide a succinct answer. 0.54. What is the ratio of the Value added (% of GDP) of Brunei Darussalam in 2010 to that in 2011?
Your response must be concise. 1.2. What is the ratio of the Value added (% of GDP) in Gabon in 2010 to that in 2011?
Provide a short and direct response. 1.18. What is the ratio of the Value added (% of GDP) in Germany in 2010 to that in 2011?
Keep it short and to the point. 1.01. What is the ratio of the Value added (% of GDP) of Nigeria in 2010 to that in 2011?
Provide a succinct answer. 1.03. What is the ratio of the Value added (% of GDP) of Brunei Darussalam in 2010 to that in 2012?
Provide a short and direct response. 1.15. What is the ratio of the Value added (% of GDP) of Gabon in 2010 to that in 2012?
Your answer should be compact. 1.1. What is the ratio of the Value added (% of GDP) of Germany in 2010 to that in 2012?
Ensure brevity in your answer.  1.01. What is the ratio of the Value added (% of GDP) in Brunei Darussalam in 2010 to that in 2013?
Offer a very short reply. 1.05. What is the ratio of the Value added (% of GDP) in Gabon in 2010 to that in 2013?
Your answer should be very brief. 1.02. What is the ratio of the Value added (% of GDP) in Nigeria in 2010 to that in 2013?
Give a very brief answer. 0.95. What is the ratio of the Value added (% of GDP) of Brunei Darussalam in 2011 to that in 2012?
Your answer should be compact. 0.96. What is the ratio of the Value added (% of GDP) in Gabon in 2011 to that in 2012?
Your answer should be very brief. 0.93. What is the ratio of the Value added (% of GDP) in Germany in 2011 to that in 2012?
Your answer should be very brief. 1. What is the ratio of the Value added (% of GDP) in Nigeria in 2011 to that in 2012?
Offer a terse response. 0.97. What is the ratio of the Value added (% of GDP) of Brunei Darussalam in 2011 to that in 2013?
Keep it short and to the point. 0.87. What is the ratio of the Value added (% of GDP) in Gabon in 2011 to that in 2013?
Your response must be concise. 0.86. What is the ratio of the Value added (% of GDP) of Nigeria in 2011 to that in 2013?
Your response must be concise. 0.93. What is the ratio of the Value added (% of GDP) in Brunei Darussalam in 2012 to that in 2013?
Provide a succinct answer. 0.91. What is the ratio of the Value added (% of GDP) in Gabon in 2012 to that in 2013?
Ensure brevity in your answer.  0.93. What is the ratio of the Value added (% of GDP) of Nigeria in 2012 to that in 2013?
Provide a short and direct response. 0.95. What is the difference between the highest and the second highest Value added (% of GDP) of Brunei Darussalam?
Offer a very short reply. 1.22. What is the difference between the highest and the second highest Value added (% of GDP) in Gabon?
Make the answer very short. 2.27. What is the difference between the highest and the second highest Value added (% of GDP) of Germany?
Ensure brevity in your answer.  2.34. What is the difference between the highest and the second highest Value added (% of GDP) in Nigeria?
Make the answer very short. 2.45. What is the difference between the highest and the lowest Value added (% of GDP) in Brunei Darussalam?
Offer a very short reply. 8.43. What is the difference between the highest and the lowest Value added (% of GDP) of Gabon?
Offer a terse response. 8.29. What is the difference between the highest and the lowest Value added (% of GDP) in Germany?
Provide a succinct answer. 3.03. What is the difference between the highest and the lowest Value added (% of GDP) of Nigeria?
Provide a short and direct response. 28. 